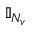<formula> <loc_0><loc_0><loc_500><loc_500>\mathbb { I } _ { N _ { v } }</formula> 